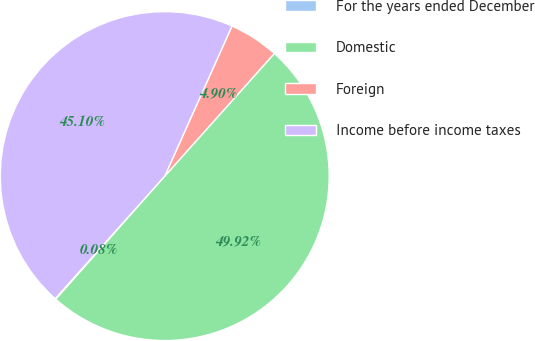Convert chart to OTSL. <chart><loc_0><loc_0><loc_500><loc_500><pie_chart><fcel>For the years ended December<fcel>Domestic<fcel>Foreign<fcel>Income before income taxes<nl><fcel>0.08%<fcel>49.92%<fcel>4.9%<fcel>45.1%<nl></chart> 